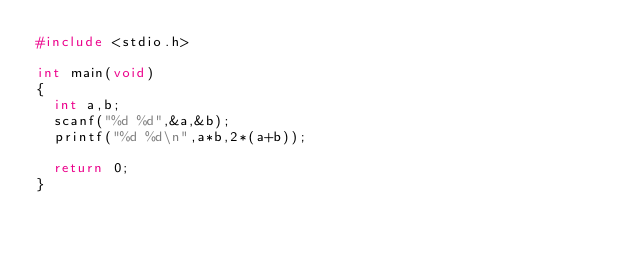<code> <loc_0><loc_0><loc_500><loc_500><_C_>#include <stdio.h>

int main(void)
{
	int a,b;
	scanf("%d %d",&a,&b);
	printf("%d %d\n",a*b,2*(a+b));
	
	return 0;
}

</code> 